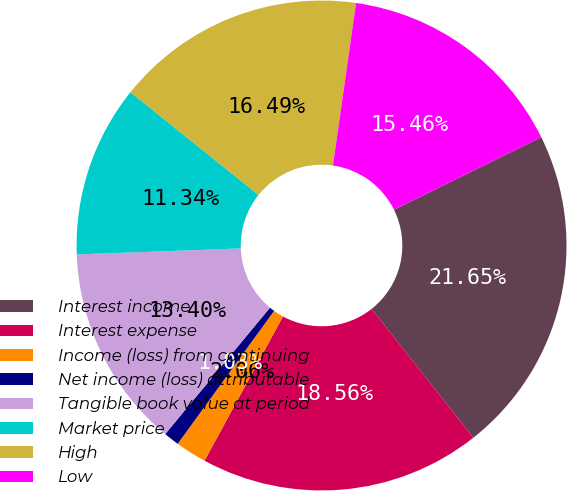<chart> <loc_0><loc_0><loc_500><loc_500><pie_chart><fcel>Interest income<fcel>Interest expense<fcel>Income (loss) from continuing<fcel>Net income (loss) attributable<fcel>Tangible book value at period<fcel>Market price<fcel>High<fcel>Low<nl><fcel>21.65%<fcel>18.56%<fcel>2.06%<fcel>1.03%<fcel>13.4%<fcel>11.34%<fcel>16.49%<fcel>15.46%<nl></chart> 